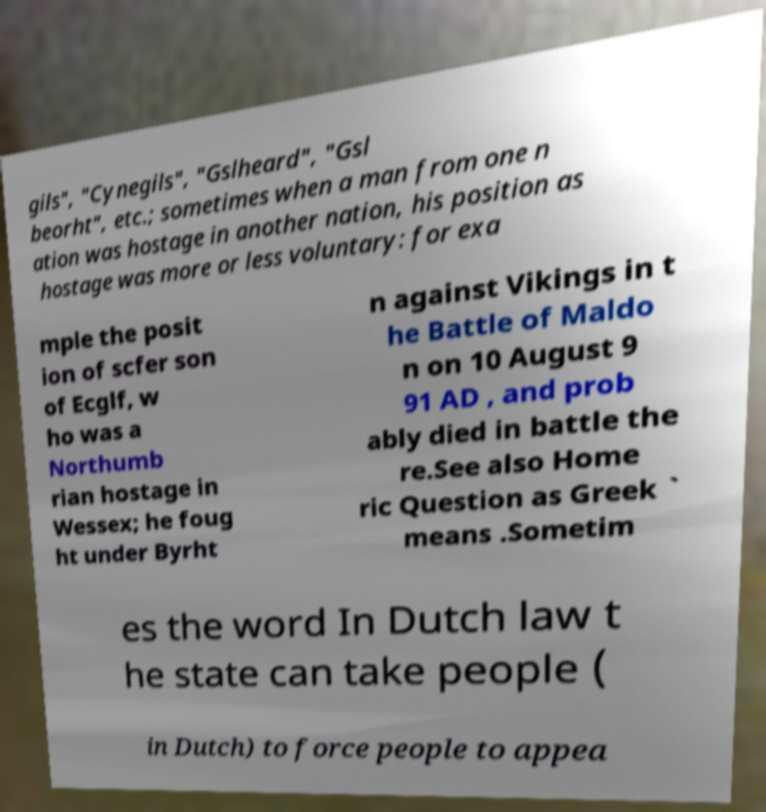Can you accurately transcribe the text from the provided image for me? gils", "Cynegils", "Gslheard", "Gsl beorht", etc.; sometimes when a man from one n ation was hostage in another nation, his position as hostage was more or less voluntary: for exa mple the posit ion of scfer son of Ecglf, w ho was a Northumb rian hostage in Wessex; he foug ht under Byrht n against Vikings in t he Battle of Maldo n on 10 August 9 91 AD , and prob ably died in battle the re.See also Home ric Question as Greek ` means .Sometim es the word In Dutch law t he state can take people ( in Dutch) to force people to appea 